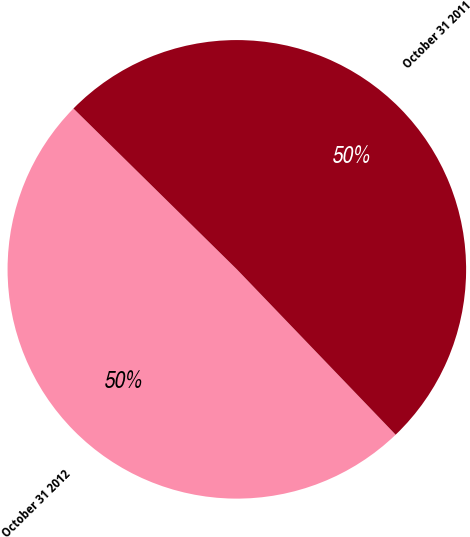<chart> <loc_0><loc_0><loc_500><loc_500><pie_chart><fcel>October 31 2012<fcel>October 31 2011<nl><fcel>49.55%<fcel>50.45%<nl></chart> 